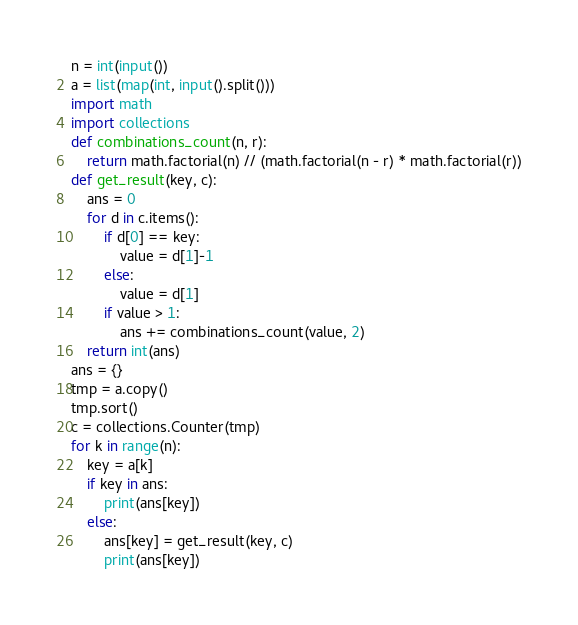<code> <loc_0><loc_0><loc_500><loc_500><_Python_>n = int(input())
a = list(map(int, input().split()))
import math
import collections
def combinations_count(n, r):
    return math.factorial(n) // (math.factorial(n - r) * math.factorial(r))
def get_result(key, c):
    ans = 0
    for d in c.items():
        if d[0] == key:
            value = d[1]-1
        else:
            value = d[1]
        if value > 1:
            ans += combinations_count(value, 2)
    return int(ans)
ans = {}
tmp = a.copy()
tmp.sort()
c = collections.Counter(tmp)
for k in range(n):
    key = a[k]
    if key in ans:
        print(ans[key])
    else:
        ans[key] = get_result(key, c)
        print(ans[key])</code> 